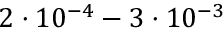<formula> <loc_0><loc_0><loc_500><loc_500>2 \cdot 1 0 ^ { - 4 } - 3 \cdot 1 0 ^ { - 3 }</formula> 